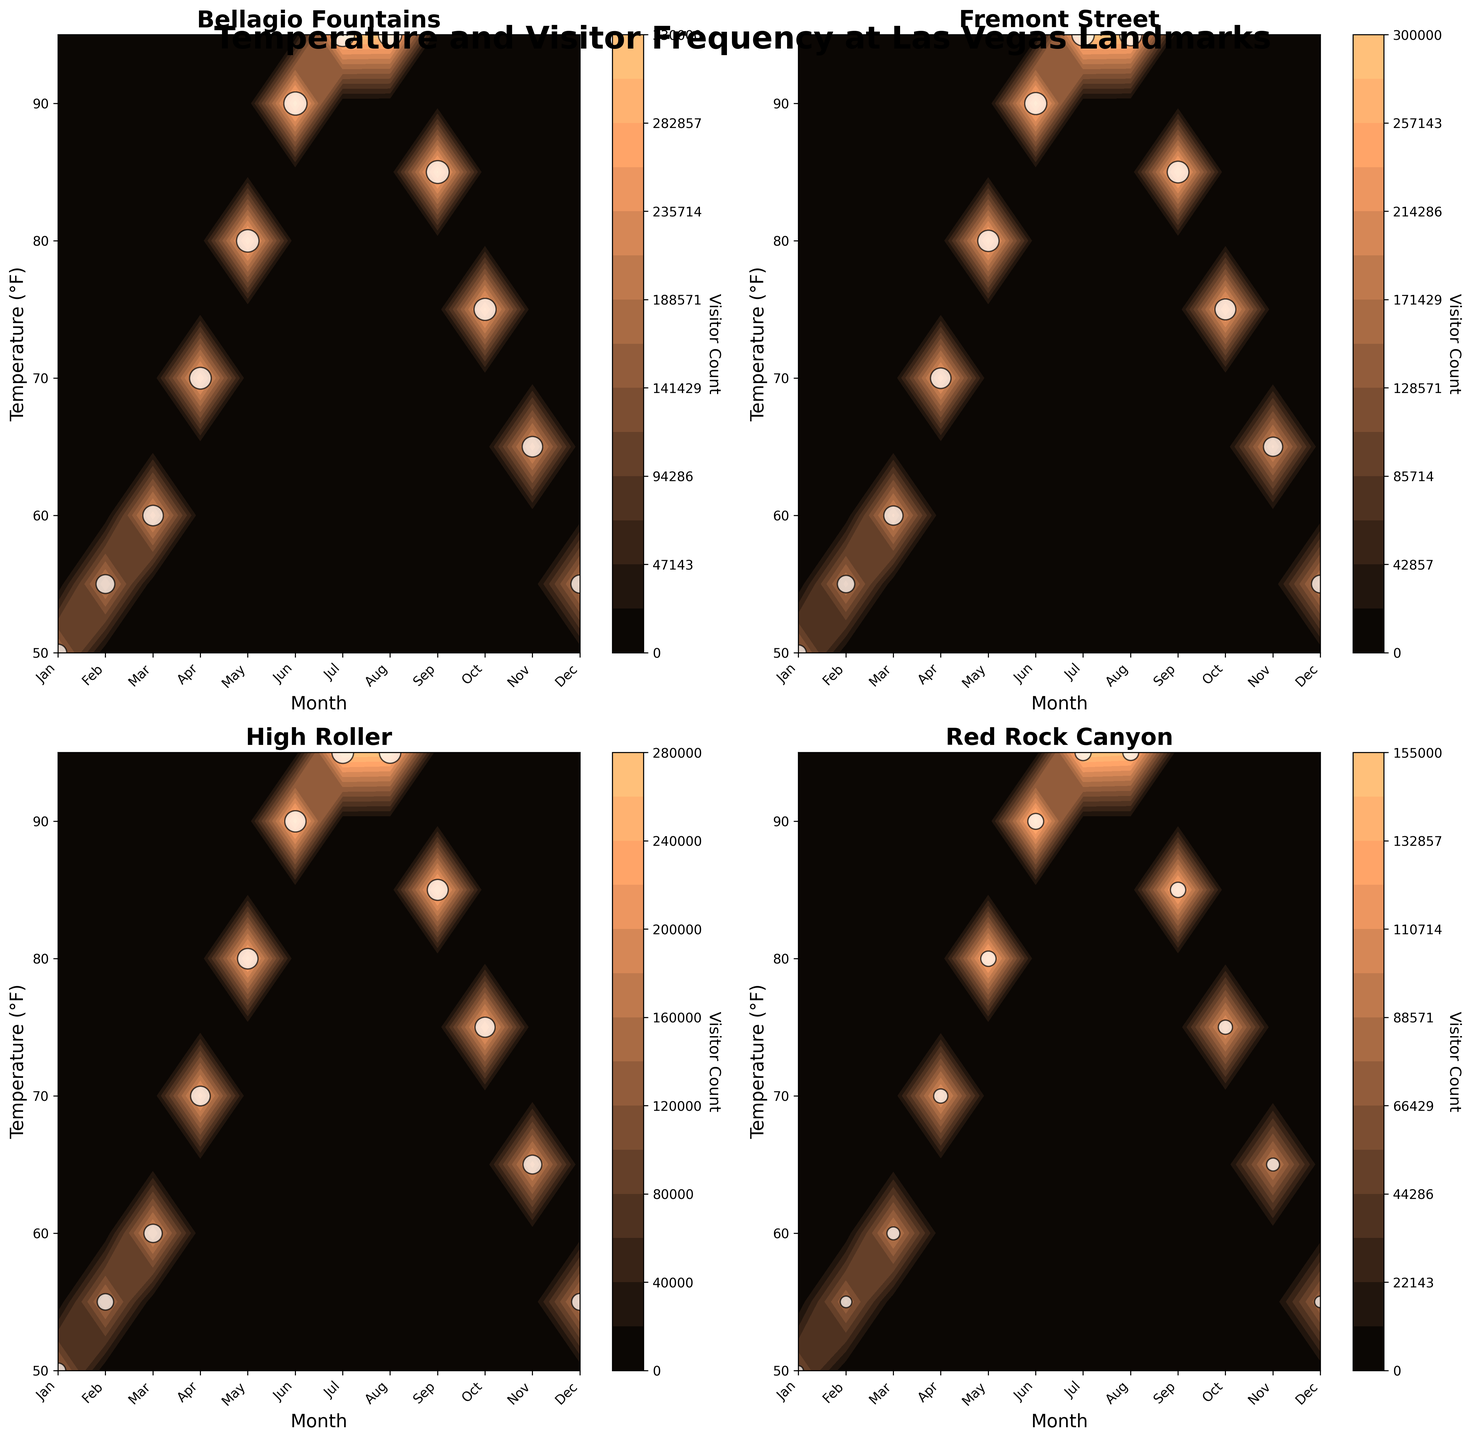Which landmark receives the highest number of visitors in July? To find the answer, look at the visitor count data for each landmark in the subplot for July. Bellagio Fountains have 330,000 visitors, Fremont Street has 300,000 visitors, High Roller has 280,000 visitors, and Red Rock Canyon has 155,000 visitors. The Bellagio Fountains have the highest number.
Answer: Bellagio Fountains What is the temperature range covered in the subplots? Examine the y-axis of the subplots. The temperature ranges from 50°F to 95°F.
Answer: 50°F to 95°F Which month shows the maximum visitor count for Red Rock Canyon? Check the contour plot for Red Rock Canyon to find which month has the highest visitor count. July has the maximum count with 155,000 visitors.
Answer: July How many distinct temperature levels are displayed in the contour plots? Identify the contours by looking at the y-axis tick marks differently spaced intervals. There are 10 distinct temperature levels, from 50°F to 95°F with intervals of 5°F.
Answer: 10 levels Compare the visitor counts in February for the Bellagio Fountains and Fremont Street. For February, look at the specific landmark data points. Bellagio Fountains has 210,000 visitors, and Fremont Street has 180,000 visitors. Bellagio Fountains has a higher visitor count.
Answer: Bellagio Fountains higher What is the general trend in visitor count for the High Roller as temperature increases? Analyze the contour plot for the High Roller. Visitor count increases as temperature increases up to July and then begins to decline slightly.
Answer: Increases then slightly declines Which landmark has the least visitors in December, and what is the count? Refer to the December visitor count for each landmark. Red Rock Canyon has the least visitors in December with 80,000 visitors.
Answer: Red Rock Canyon, 80,000 Which month appears to have the highest overall visitor counts across all landmarks? Check across all subplots for the month with the darkest shaded contours or highest data points. July generally appears to have the highest visitor counts.
Answer: July Does the visitor count for Fremont Street exceed 250,000 in May? Check the contour plot and specific data points for Fremont Street in May. The visitor count is 270,000, which exceeds 250,000.
Answer: Yes How does the visitor count for the Bellagio Fountains vary between March and November? Look at the visitor counts for the Bellagio Fountains in March and November. March has 250,000 visitors while November has 250,000 visitors. The counts are equal.
Answer: Equal 